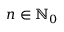Convert formula to latex. <formula><loc_0><loc_0><loc_500><loc_500>n \in \mathbb { N } _ { 0 }</formula> 